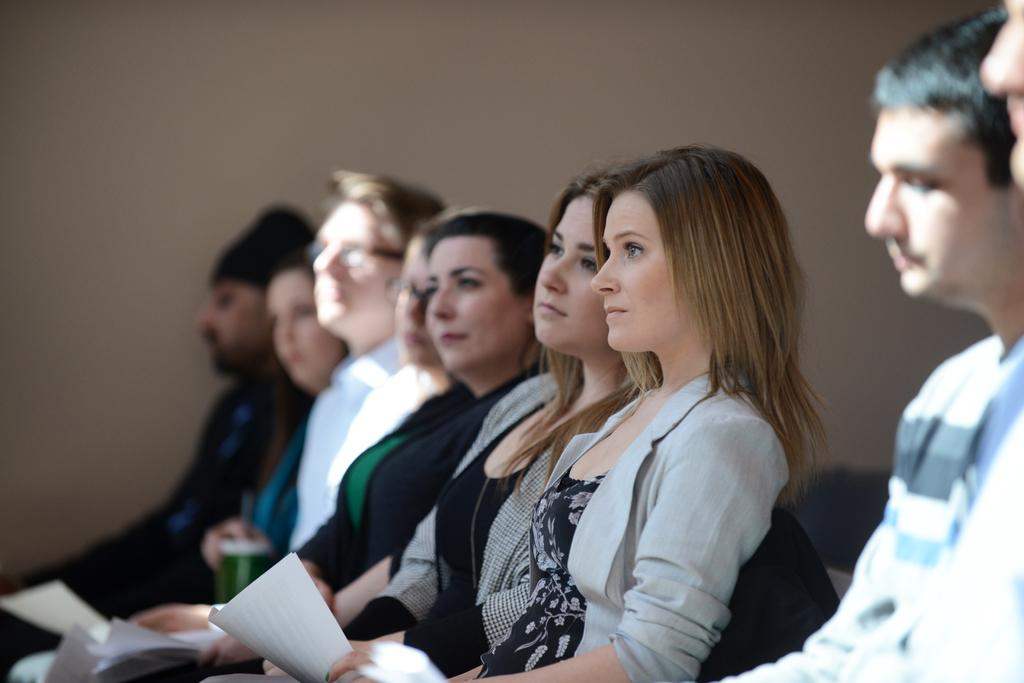How many individuals are present in the image? There are many people in the image. What are the people wearing? The people are wearing clothes. What are the people doing in the image? The people are sitting. What can be seen in the image besides the people? There is a paper and an object in the image. What type of cherry is being used to fix the clock in the image? There is no cherry or clock present in the image. What is the hammer being used for in the image? There is no hammer present in the image. 